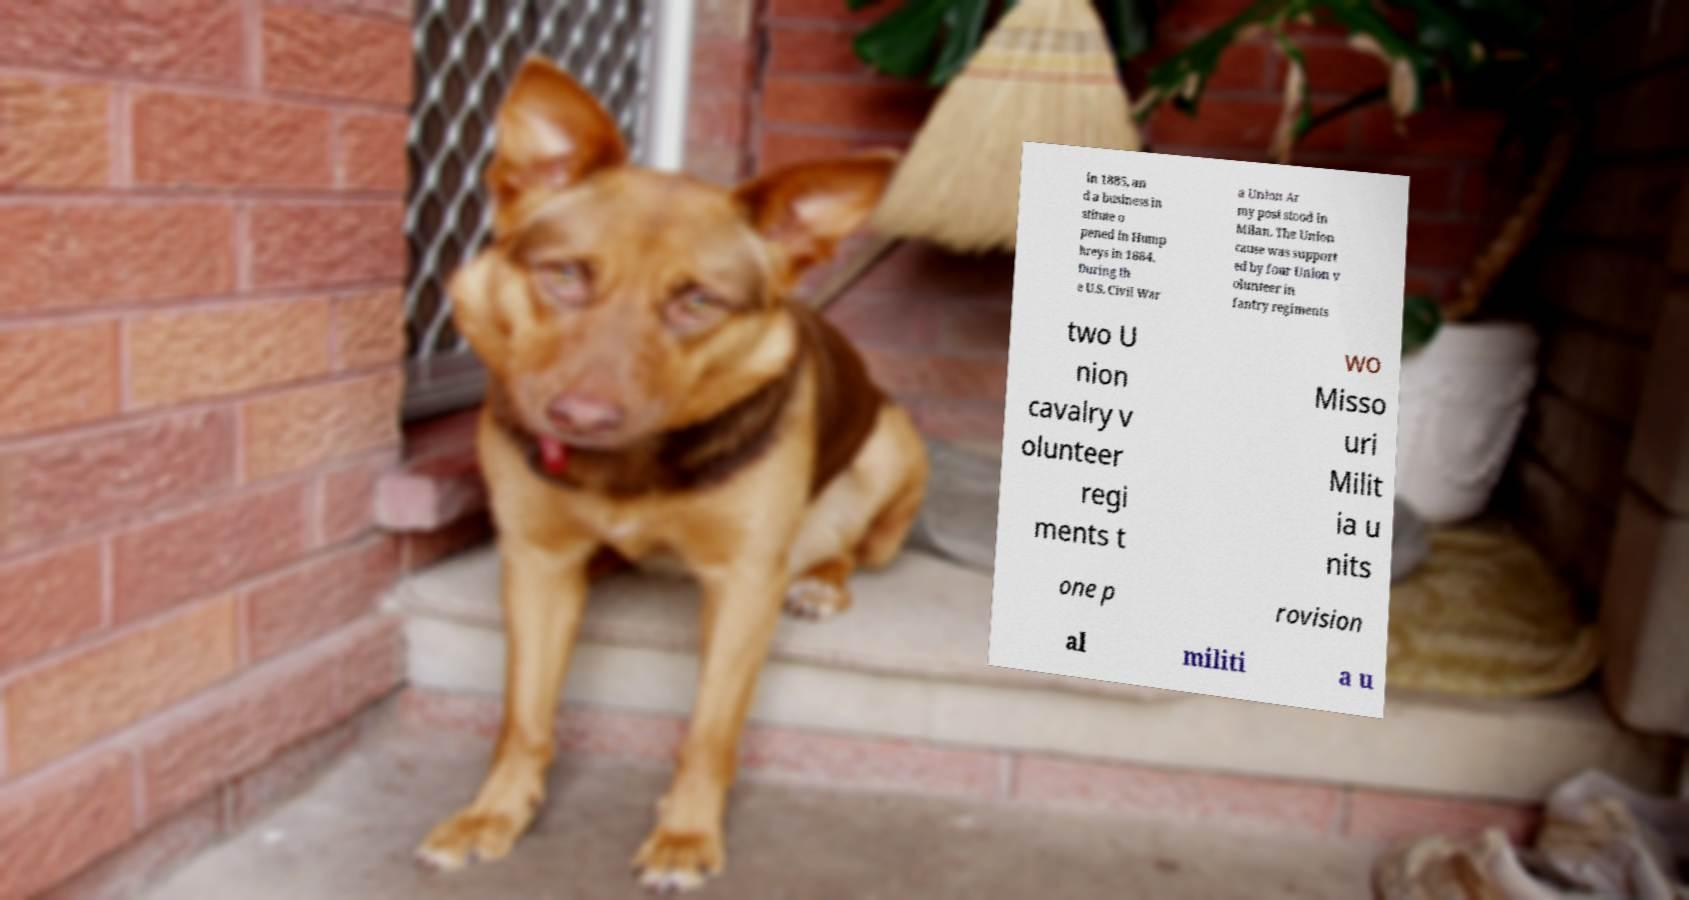Please identify and transcribe the text found in this image. in 1885, an d a business in stitute o pened in Hump hreys in 1884. During th e U.S. Civil War a Union Ar my post stood in Milan. The Union cause was support ed by four Union v olunteer in fantry regiments two U nion cavalry v olunteer regi ments t wo Misso uri Milit ia u nits one p rovision al militi a u 